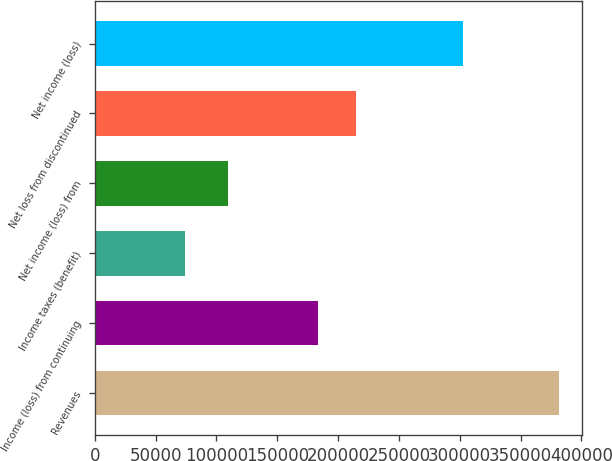<chart> <loc_0><loc_0><loc_500><loc_500><bar_chart><fcel>Revenues<fcel>Income (loss) from continuing<fcel>Income taxes (benefit)<fcel>Net income (loss) from<fcel>Net loss from discontinued<fcel>Net income (loss)<nl><fcel>381209<fcel>183580<fcel>73757<fcel>109823<fcel>214325<fcel>302580<nl></chart> 